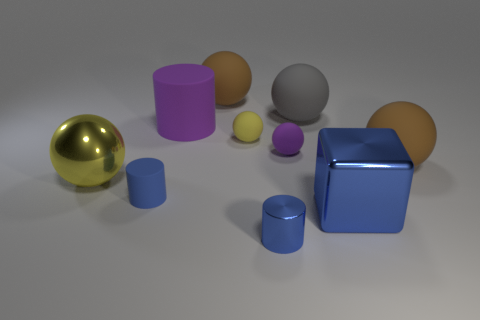Subtract all gray spheres. How many spheres are left? 5 Subtract 2 spheres. How many spheres are left? 4 Subtract all large gray matte balls. How many balls are left? 5 Subtract all blue spheres. Subtract all red cubes. How many spheres are left? 6 Subtract all cylinders. How many objects are left? 7 Add 2 yellow spheres. How many yellow spheres are left? 4 Add 7 purple things. How many purple things exist? 9 Subtract 0 cyan cylinders. How many objects are left? 10 Subtract all yellow objects. Subtract all big gray rubber things. How many objects are left? 7 